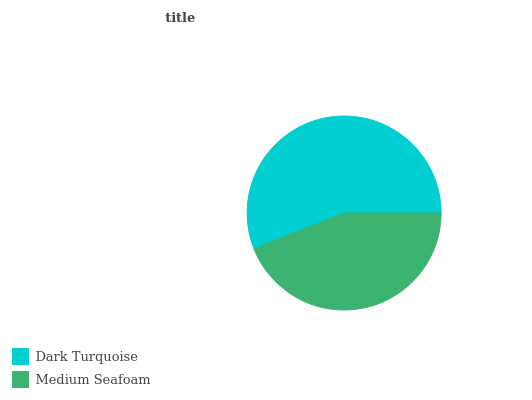Is Medium Seafoam the minimum?
Answer yes or no. Yes. Is Dark Turquoise the maximum?
Answer yes or no. Yes. Is Medium Seafoam the maximum?
Answer yes or no. No. Is Dark Turquoise greater than Medium Seafoam?
Answer yes or no. Yes. Is Medium Seafoam less than Dark Turquoise?
Answer yes or no. Yes. Is Medium Seafoam greater than Dark Turquoise?
Answer yes or no. No. Is Dark Turquoise less than Medium Seafoam?
Answer yes or no. No. Is Dark Turquoise the high median?
Answer yes or no. Yes. Is Medium Seafoam the low median?
Answer yes or no. Yes. Is Medium Seafoam the high median?
Answer yes or no. No. Is Dark Turquoise the low median?
Answer yes or no. No. 